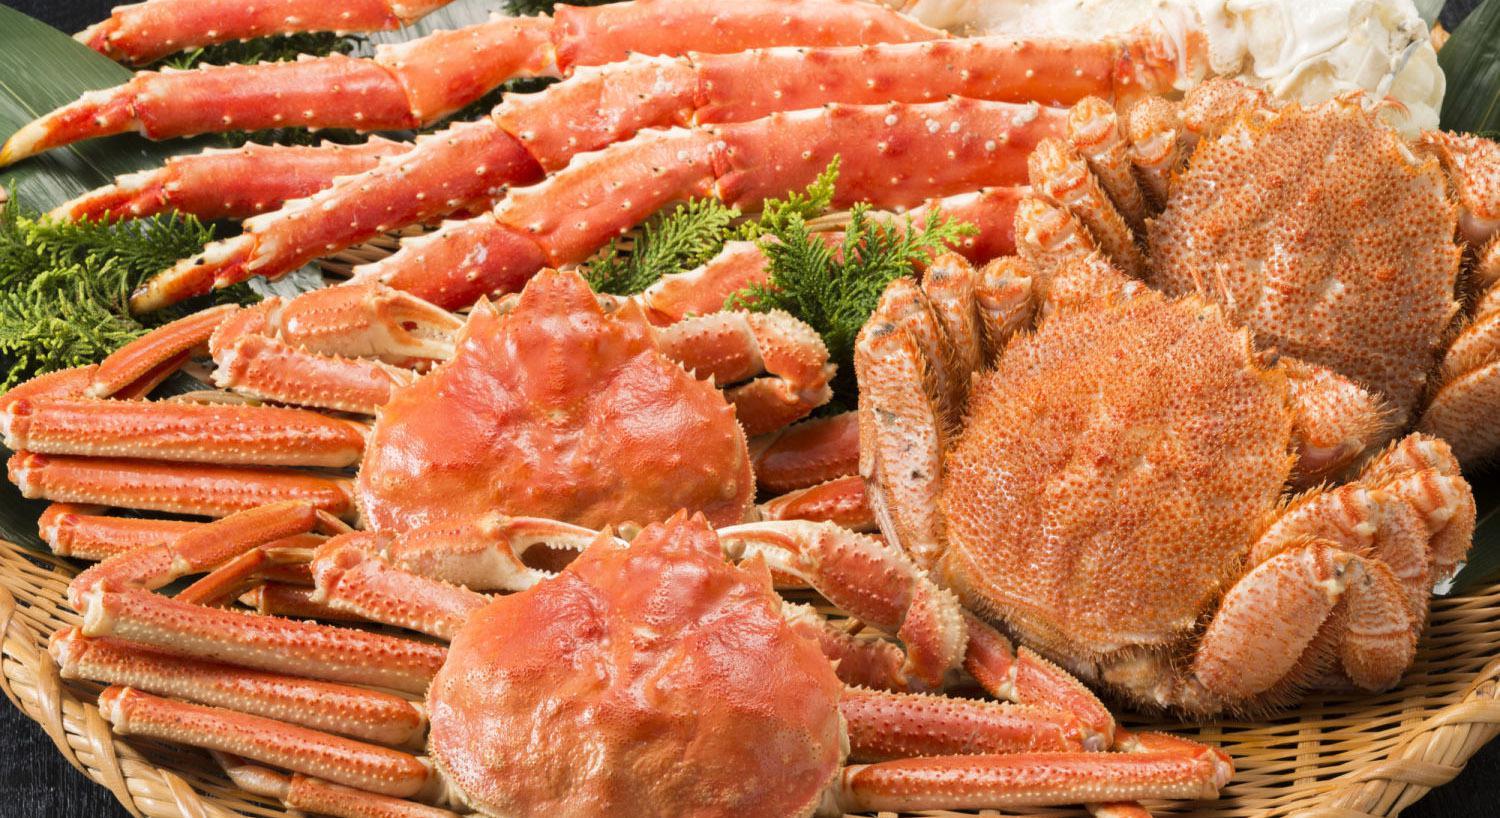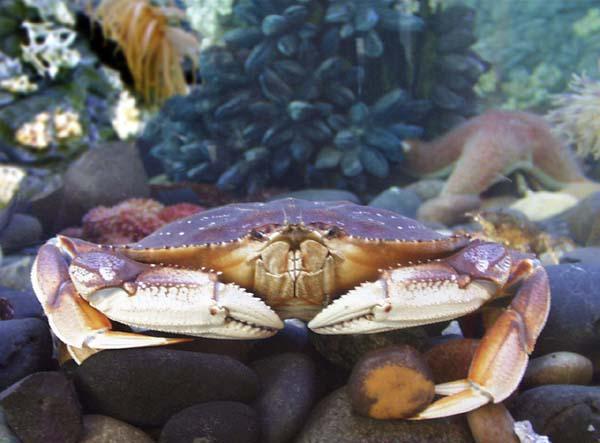The first image is the image on the left, the second image is the image on the right. Given the left and right images, does the statement "In the right image there is a single crab facing the camera." hold true? Answer yes or no. Yes. The first image is the image on the left, the second image is the image on the right. Evaluate the accuracy of this statement regarding the images: "Five or fewer crab bodies are visible.". Is it true? Answer yes or no. Yes. 